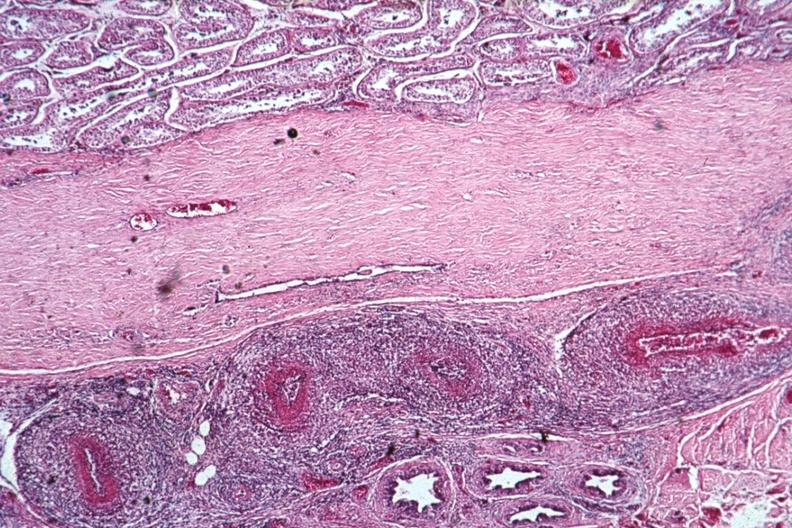s rheumatoid arthritis with vasculitis present?
Answer the question using a single word or phrase. Yes 